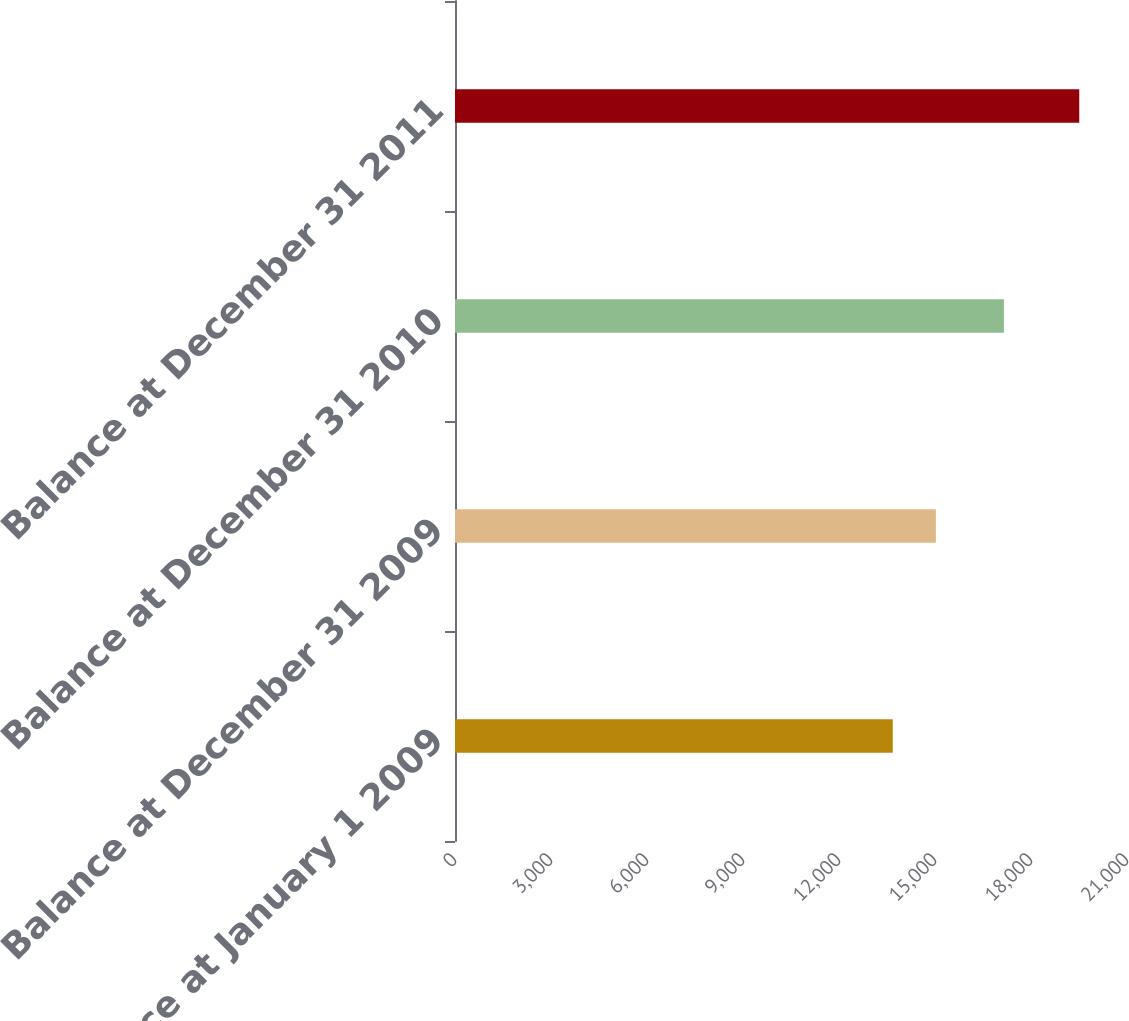Convert chart. <chart><loc_0><loc_0><loc_500><loc_500><bar_chart><fcel>Balance at January 1 2009<fcel>Balance at December 31 2009<fcel>Balance at December 31 2010<fcel>Balance at December 31 2011<nl><fcel>13681<fcel>15027<fcel>17154<fcel>19508<nl></chart> 